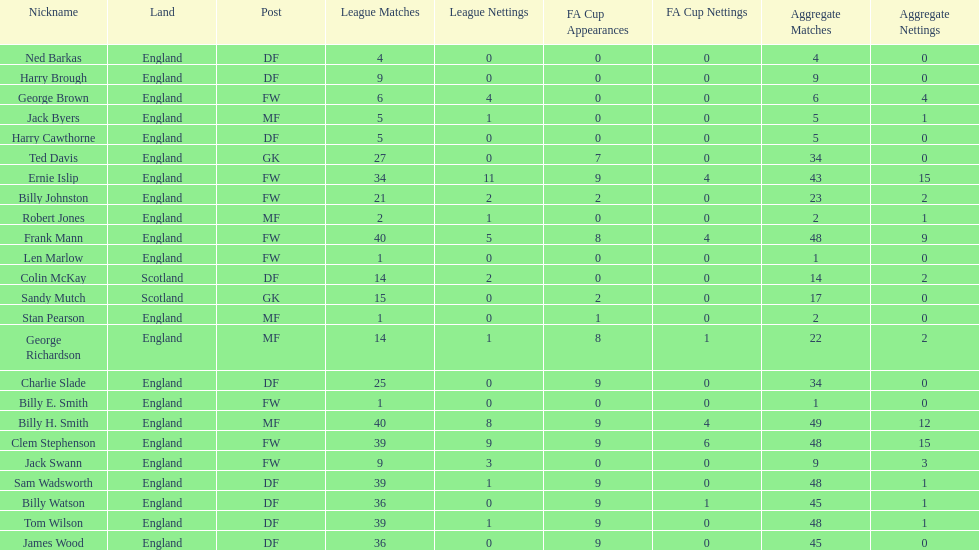Which position is listed the least amount of times on this chart? GK. 